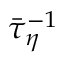<formula> <loc_0><loc_0><loc_500><loc_500>\bar { \tau } _ { \eta } ^ { - 1 }</formula> 